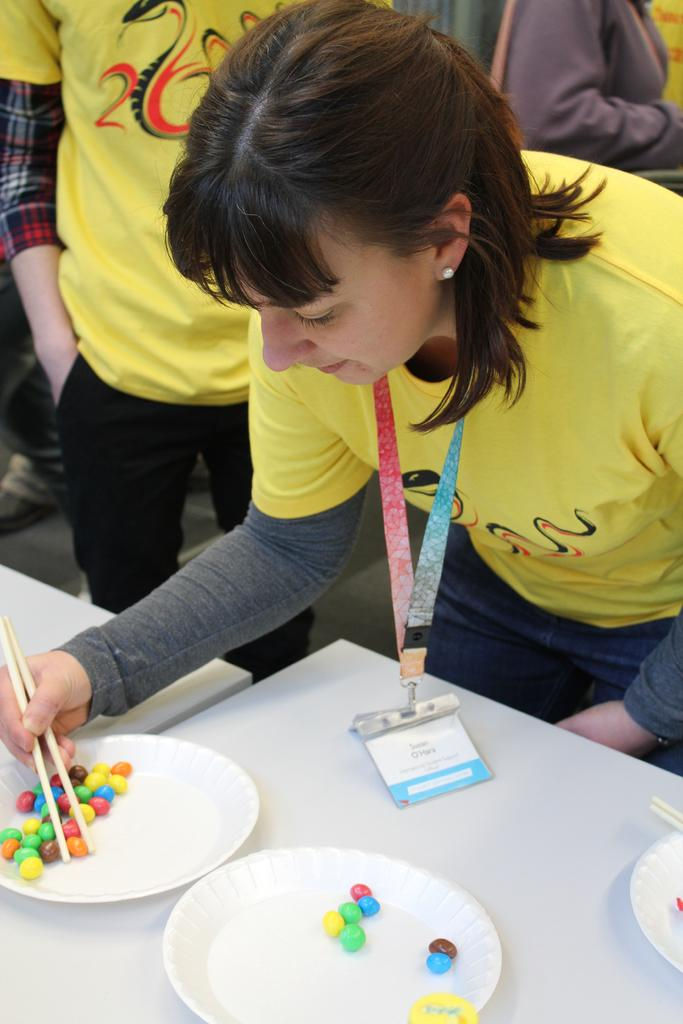What is the person in the image holding? The person in the image is holding chopsticks. What type of furniture is present in the image? There are tables in the image. What is on one of the tables? There are plates on one of the tables. What else can be seen on the table? There are objects on one of the tables. Can you describe the people in the background of the image? There are people visible in the background of the image. What type of hose is being used by the person in the image? There is no hose present in the image; the person is holding chopsticks. Is there a cow visible in the image? No, there is no cow present in the image. 